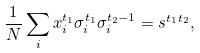<formula> <loc_0><loc_0><loc_500><loc_500>\frac { 1 } { N } \sum _ { i } x _ { i } ^ { t _ { 1 } } \sigma _ { i } ^ { t _ { 1 } } \sigma _ { i } ^ { t _ { 2 } - 1 } = s ^ { t _ { 1 } t _ { 2 } } ,</formula> 